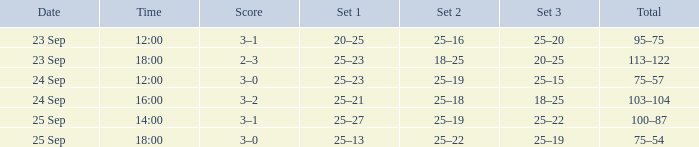What was the score when the time was 14:00? 3–1. 